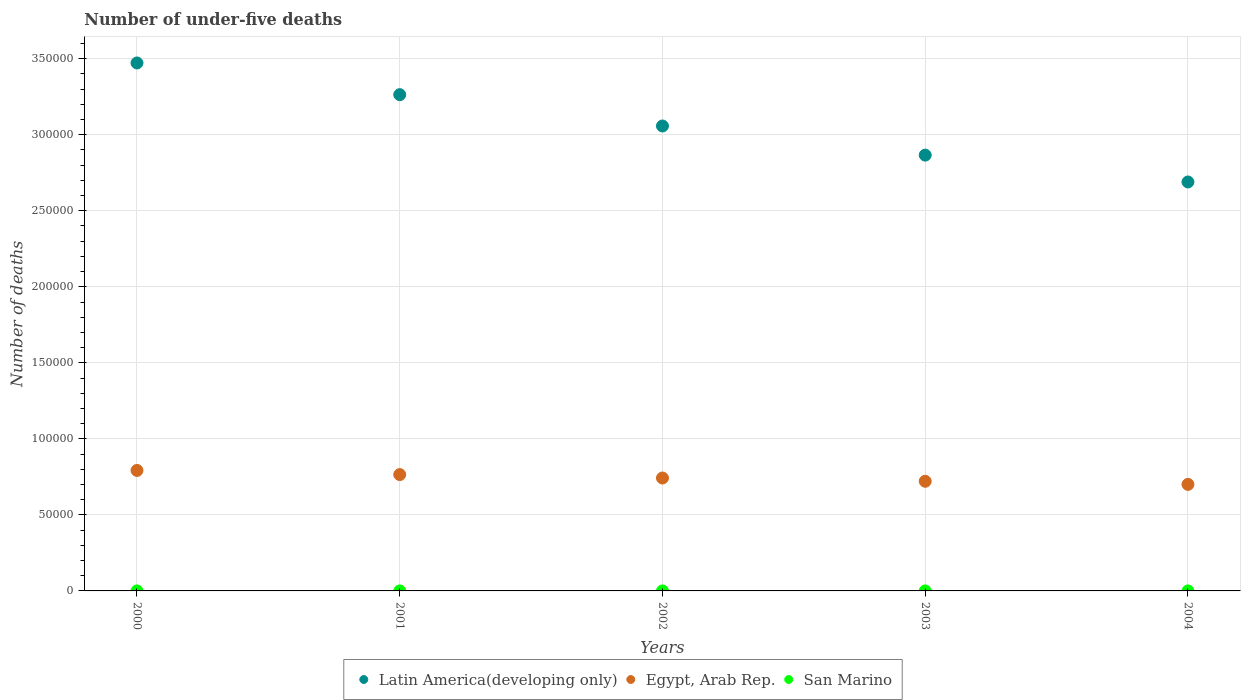What is the number of under-five deaths in Egypt, Arab Rep. in 2002?
Keep it short and to the point. 7.43e+04. Across all years, what is the maximum number of under-five deaths in Latin America(developing only)?
Provide a succinct answer. 3.47e+05. Across all years, what is the minimum number of under-five deaths in Latin America(developing only)?
Your answer should be very brief. 2.69e+05. What is the total number of under-five deaths in San Marino in the graph?
Keep it short and to the point. 5. What is the difference between the number of under-five deaths in Egypt, Arab Rep. in 2000 and that in 2004?
Offer a terse response. 9179. What is the difference between the number of under-five deaths in Latin America(developing only) in 2003 and the number of under-five deaths in San Marino in 2001?
Offer a terse response. 2.87e+05. What is the average number of under-five deaths in Egypt, Arab Rep. per year?
Your response must be concise. 7.44e+04. In the year 2003, what is the difference between the number of under-five deaths in San Marino and number of under-five deaths in Latin America(developing only)?
Make the answer very short. -2.87e+05. In how many years, is the number of under-five deaths in Egypt, Arab Rep. greater than 100000?
Your answer should be compact. 0. What is the ratio of the number of under-five deaths in Egypt, Arab Rep. in 2001 to that in 2002?
Your response must be concise. 1.03. Is the number of under-five deaths in Egypt, Arab Rep. in 2000 less than that in 2004?
Offer a terse response. No. Is the difference between the number of under-five deaths in San Marino in 2001 and 2004 greater than the difference between the number of under-five deaths in Latin America(developing only) in 2001 and 2004?
Your response must be concise. No. What is the difference between the highest and the second highest number of under-five deaths in Latin America(developing only)?
Provide a succinct answer. 2.08e+04. What is the difference between the highest and the lowest number of under-five deaths in Egypt, Arab Rep.?
Give a very brief answer. 9179. Is the sum of the number of under-five deaths in Egypt, Arab Rep. in 2000 and 2001 greater than the maximum number of under-five deaths in Latin America(developing only) across all years?
Give a very brief answer. No. Is it the case that in every year, the sum of the number of under-five deaths in Latin America(developing only) and number of under-five deaths in Egypt, Arab Rep.  is greater than the number of under-five deaths in San Marino?
Keep it short and to the point. Yes. How many dotlines are there?
Make the answer very short. 3. Are the values on the major ticks of Y-axis written in scientific E-notation?
Your response must be concise. No. Does the graph contain grids?
Provide a succinct answer. Yes. What is the title of the graph?
Your response must be concise. Number of under-five deaths. What is the label or title of the Y-axis?
Offer a very short reply. Number of deaths. What is the Number of deaths in Latin America(developing only) in 2000?
Offer a terse response. 3.47e+05. What is the Number of deaths in Egypt, Arab Rep. in 2000?
Your answer should be compact. 7.92e+04. What is the Number of deaths of San Marino in 2000?
Make the answer very short. 1. What is the Number of deaths in Latin America(developing only) in 2001?
Your answer should be very brief. 3.26e+05. What is the Number of deaths in Egypt, Arab Rep. in 2001?
Provide a succinct answer. 7.65e+04. What is the Number of deaths in Latin America(developing only) in 2002?
Keep it short and to the point. 3.06e+05. What is the Number of deaths of Egypt, Arab Rep. in 2002?
Provide a succinct answer. 7.43e+04. What is the Number of deaths in San Marino in 2002?
Ensure brevity in your answer.  1. What is the Number of deaths in Latin America(developing only) in 2003?
Offer a terse response. 2.87e+05. What is the Number of deaths in Egypt, Arab Rep. in 2003?
Provide a succinct answer. 7.21e+04. What is the Number of deaths in Latin America(developing only) in 2004?
Give a very brief answer. 2.69e+05. What is the Number of deaths in Egypt, Arab Rep. in 2004?
Make the answer very short. 7.01e+04. What is the Number of deaths of San Marino in 2004?
Provide a succinct answer. 1. Across all years, what is the maximum Number of deaths of Latin America(developing only)?
Offer a terse response. 3.47e+05. Across all years, what is the maximum Number of deaths in Egypt, Arab Rep.?
Provide a short and direct response. 7.92e+04. Across all years, what is the maximum Number of deaths of San Marino?
Ensure brevity in your answer.  1. Across all years, what is the minimum Number of deaths of Latin America(developing only)?
Provide a succinct answer. 2.69e+05. Across all years, what is the minimum Number of deaths of Egypt, Arab Rep.?
Offer a terse response. 7.01e+04. What is the total Number of deaths in Latin America(developing only) in the graph?
Your answer should be compact. 1.53e+06. What is the total Number of deaths of Egypt, Arab Rep. in the graph?
Your answer should be very brief. 3.72e+05. What is the total Number of deaths of San Marino in the graph?
Your answer should be very brief. 5. What is the difference between the Number of deaths in Latin America(developing only) in 2000 and that in 2001?
Make the answer very short. 2.08e+04. What is the difference between the Number of deaths of Egypt, Arab Rep. in 2000 and that in 2001?
Make the answer very short. 2722. What is the difference between the Number of deaths of San Marino in 2000 and that in 2001?
Make the answer very short. 0. What is the difference between the Number of deaths in Latin America(developing only) in 2000 and that in 2002?
Your answer should be compact. 4.14e+04. What is the difference between the Number of deaths in Egypt, Arab Rep. in 2000 and that in 2002?
Your answer should be compact. 4978. What is the difference between the Number of deaths in Latin America(developing only) in 2000 and that in 2003?
Give a very brief answer. 6.06e+04. What is the difference between the Number of deaths in Egypt, Arab Rep. in 2000 and that in 2003?
Provide a succinct answer. 7122. What is the difference between the Number of deaths of San Marino in 2000 and that in 2003?
Provide a succinct answer. 0. What is the difference between the Number of deaths in Latin America(developing only) in 2000 and that in 2004?
Your answer should be very brief. 7.83e+04. What is the difference between the Number of deaths of Egypt, Arab Rep. in 2000 and that in 2004?
Your answer should be compact. 9179. What is the difference between the Number of deaths in San Marino in 2000 and that in 2004?
Your answer should be very brief. 0. What is the difference between the Number of deaths in Latin America(developing only) in 2001 and that in 2002?
Give a very brief answer. 2.06e+04. What is the difference between the Number of deaths of Egypt, Arab Rep. in 2001 and that in 2002?
Your response must be concise. 2256. What is the difference between the Number of deaths in San Marino in 2001 and that in 2002?
Offer a terse response. 0. What is the difference between the Number of deaths in Latin America(developing only) in 2001 and that in 2003?
Your answer should be compact. 3.98e+04. What is the difference between the Number of deaths in Egypt, Arab Rep. in 2001 and that in 2003?
Your answer should be compact. 4400. What is the difference between the Number of deaths in Latin America(developing only) in 2001 and that in 2004?
Ensure brevity in your answer.  5.74e+04. What is the difference between the Number of deaths in Egypt, Arab Rep. in 2001 and that in 2004?
Your answer should be compact. 6457. What is the difference between the Number of deaths in Latin America(developing only) in 2002 and that in 2003?
Provide a short and direct response. 1.92e+04. What is the difference between the Number of deaths in Egypt, Arab Rep. in 2002 and that in 2003?
Offer a very short reply. 2144. What is the difference between the Number of deaths in San Marino in 2002 and that in 2003?
Keep it short and to the point. 0. What is the difference between the Number of deaths of Latin America(developing only) in 2002 and that in 2004?
Provide a short and direct response. 3.68e+04. What is the difference between the Number of deaths of Egypt, Arab Rep. in 2002 and that in 2004?
Keep it short and to the point. 4201. What is the difference between the Number of deaths in San Marino in 2002 and that in 2004?
Your answer should be very brief. 0. What is the difference between the Number of deaths of Latin America(developing only) in 2003 and that in 2004?
Provide a succinct answer. 1.77e+04. What is the difference between the Number of deaths of Egypt, Arab Rep. in 2003 and that in 2004?
Keep it short and to the point. 2057. What is the difference between the Number of deaths in San Marino in 2003 and that in 2004?
Keep it short and to the point. 0. What is the difference between the Number of deaths of Latin America(developing only) in 2000 and the Number of deaths of Egypt, Arab Rep. in 2001?
Provide a short and direct response. 2.71e+05. What is the difference between the Number of deaths in Latin America(developing only) in 2000 and the Number of deaths in San Marino in 2001?
Ensure brevity in your answer.  3.47e+05. What is the difference between the Number of deaths in Egypt, Arab Rep. in 2000 and the Number of deaths in San Marino in 2001?
Offer a terse response. 7.92e+04. What is the difference between the Number of deaths in Latin America(developing only) in 2000 and the Number of deaths in Egypt, Arab Rep. in 2002?
Ensure brevity in your answer.  2.73e+05. What is the difference between the Number of deaths of Latin America(developing only) in 2000 and the Number of deaths of San Marino in 2002?
Give a very brief answer. 3.47e+05. What is the difference between the Number of deaths in Egypt, Arab Rep. in 2000 and the Number of deaths in San Marino in 2002?
Offer a terse response. 7.92e+04. What is the difference between the Number of deaths in Latin America(developing only) in 2000 and the Number of deaths in Egypt, Arab Rep. in 2003?
Your response must be concise. 2.75e+05. What is the difference between the Number of deaths of Latin America(developing only) in 2000 and the Number of deaths of San Marino in 2003?
Make the answer very short. 3.47e+05. What is the difference between the Number of deaths of Egypt, Arab Rep. in 2000 and the Number of deaths of San Marino in 2003?
Keep it short and to the point. 7.92e+04. What is the difference between the Number of deaths of Latin America(developing only) in 2000 and the Number of deaths of Egypt, Arab Rep. in 2004?
Ensure brevity in your answer.  2.77e+05. What is the difference between the Number of deaths in Latin America(developing only) in 2000 and the Number of deaths in San Marino in 2004?
Your response must be concise. 3.47e+05. What is the difference between the Number of deaths in Egypt, Arab Rep. in 2000 and the Number of deaths in San Marino in 2004?
Keep it short and to the point. 7.92e+04. What is the difference between the Number of deaths in Latin America(developing only) in 2001 and the Number of deaths in Egypt, Arab Rep. in 2002?
Your response must be concise. 2.52e+05. What is the difference between the Number of deaths in Latin America(developing only) in 2001 and the Number of deaths in San Marino in 2002?
Give a very brief answer. 3.26e+05. What is the difference between the Number of deaths of Egypt, Arab Rep. in 2001 and the Number of deaths of San Marino in 2002?
Make the answer very short. 7.65e+04. What is the difference between the Number of deaths of Latin America(developing only) in 2001 and the Number of deaths of Egypt, Arab Rep. in 2003?
Your answer should be compact. 2.54e+05. What is the difference between the Number of deaths in Latin America(developing only) in 2001 and the Number of deaths in San Marino in 2003?
Your answer should be very brief. 3.26e+05. What is the difference between the Number of deaths of Egypt, Arab Rep. in 2001 and the Number of deaths of San Marino in 2003?
Your answer should be very brief. 7.65e+04. What is the difference between the Number of deaths in Latin America(developing only) in 2001 and the Number of deaths in Egypt, Arab Rep. in 2004?
Your answer should be very brief. 2.56e+05. What is the difference between the Number of deaths of Latin America(developing only) in 2001 and the Number of deaths of San Marino in 2004?
Make the answer very short. 3.26e+05. What is the difference between the Number of deaths in Egypt, Arab Rep. in 2001 and the Number of deaths in San Marino in 2004?
Keep it short and to the point. 7.65e+04. What is the difference between the Number of deaths of Latin America(developing only) in 2002 and the Number of deaths of Egypt, Arab Rep. in 2003?
Make the answer very short. 2.34e+05. What is the difference between the Number of deaths of Latin America(developing only) in 2002 and the Number of deaths of San Marino in 2003?
Your answer should be very brief. 3.06e+05. What is the difference between the Number of deaths of Egypt, Arab Rep. in 2002 and the Number of deaths of San Marino in 2003?
Keep it short and to the point. 7.43e+04. What is the difference between the Number of deaths in Latin America(developing only) in 2002 and the Number of deaths in Egypt, Arab Rep. in 2004?
Keep it short and to the point. 2.36e+05. What is the difference between the Number of deaths of Latin America(developing only) in 2002 and the Number of deaths of San Marino in 2004?
Ensure brevity in your answer.  3.06e+05. What is the difference between the Number of deaths of Egypt, Arab Rep. in 2002 and the Number of deaths of San Marino in 2004?
Provide a succinct answer. 7.43e+04. What is the difference between the Number of deaths in Latin America(developing only) in 2003 and the Number of deaths in Egypt, Arab Rep. in 2004?
Provide a succinct answer. 2.17e+05. What is the difference between the Number of deaths in Latin America(developing only) in 2003 and the Number of deaths in San Marino in 2004?
Offer a terse response. 2.87e+05. What is the difference between the Number of deaths of Egypt, Arab Rep. in 2003 and the Number of deaths of San Marino in 2004?
Ensure brevity in your answer.  7.21e+04. What is the average Number of deaths of Latin America(developing only) per year?
Your response must be concise. 3.07e+05. What is the average Number of deaths in Egypt, Arab Rep. per year?
Offer a very short reply. 7.44e+04. In the year 2000, what is the difference between the Number of deaths in Latin America(developing only) and Number of deaths in Egypt, Arab Rep.?
Offer a terse response. 2.68e+05. In the year 2000, what is the difference between the Number of deaths of Latin America(developing only) and Number of deaths of San Marino?
Provide a short and direct response. 3.47e+05. In the year 2000, what is the difference between the Number of deaths in Egypt, Arab Rep. and Number of deaths in San Marino?
Keep it short and to the point. 7.92e+04. In the year 2001, what is the difference between the Number of deaths of Latin America(developing only) and Number of deaths of Egypt, Arab Rep.?
Your answer should be very brief. 2.50e+05. In the year 2001, what is the difference between the Number of deaths in Latin America(developing only) and Number of deaths in San Marino?
Your response must be concise. 3.26e+05. In the year 2001, what is the difference between the Number of deaths in Egypt, Arab Rep. and Number of deaths in San Marino?
Your answer should be very brief. 7.65e+04. In the year 2002, what is the difference between the Number of deaths in Latin America(developing only) and Number of deaths in Egypt, Arab Rep.?
Make the answer very short. 2.31e+05. In the year 2002, what is the difference between the Number of deaths in Latin America(developing only) and Number of deaths in San Marino?
Your answer should be very brief. 3.06e+05. In the year 2002, what is the difference between the Number of deaths of Egypt, Arab Rep. and Number of deaths of San Marino?
Ensure brevity in your answer.  7.43e+04. In the year 2003, what is the difference between the Number of deaths of Latin America(developing only) and Number of deaths of Egypt, Arab Rep.?
Your answer should be compact. 2.14e+05. In the year 2003, what is the difference between the Number of deaths of Latin America(developing only) and Number of deaths of San Marino?
Provide a short and direct response. 2.87e+05. In the year 2003, what is the difference between the Number of deaths of Egypt, Arab Rep. and Number of deaths of San Marino?
Keep it short and to the point. 7.21e+04. In the year 2004, what is the difference between the Number of deaths in Latin America(developing only) and Number of deaths in Egypt, Arab Rep.?
Your answer should be very brief. 1.99e+05. In the year 2004, what is the difference between the Number of deaths in Latin America(developing only) and Number of deaths in San Marino?
Make the answer very short. 2.69e+05. In the year 2004, what is the difference between the Number of deaths of Egypt, Arab Rep. and Number of deaths of San Marino?
Your answer should be very brief. 7.01e+04. What is the ratio of the Number of deaths of Latin America(developing only) in 2000 to that in 2001?
Give a very brief answer. 1.06. What is the ratio of the Number of deaths in Egypt, Arab Rep. in 2000 to that in 2001?
Give a very brief answer. 1.04. What is the ratio of the Number of deaths in San Marino in 2000 to that in 2001?
Provide a short and direct response. 1. What is the ratio of the Number of deaths of Latin America(developing only) in 2000 to that in 2002?
Your response must be concise. 1.14. What is the ratio of the Number of deaths in Egypt, Arab Rep. in 2000 to that in 2002?
Make the answer very short. 1.07. What is the ratio of the Number of deaths in San Marino in 2000 to that in 2002?
Your response must be concise. 1. What is the ratio of the Number of deaths of Latin America(developing only) in 2000 to that in 2003?
Provide a short and direct response. 1.21. What is the ratio of the Number of deaths of Egypt, Arab Rep. in 2000 to that in 2003?
Your response must be concise. 1.1. What is the ratio of the Number of deaths in Latin America(developing only) in 2000 to that in 2004?
Offer a very short reply. 1.29. What is the ratio of the Number of deaths of Egypt, Arab Rep. in 2000 to that in 2004?
Your answer should be compact. 1.13. What is the ratio of the Number of deaths in San Marino in 2000 to that in 2004?
Your answer should be compact. 1. What is the ratio of the Number of deaths in Latin America(developing only) in 2001 to that in 2002?
Make the answer very short. 1.07. What is the ratio of the Number of deaths of Egypt, Arab Rep. in 2001 to that in 2002?
Keep it short and to the point. 1.03. What is the ratio of the Number of deaths in Latin America(developing only) in 2001 to that in 2003?
Keep it short and to the point. 1.14. What is the ratio of the Number of deaths in Egypt, Arab Rep. in 2001 to that in 2003?
Your response must be concise. 1.06. What is the ratio of the Number of deaths in San Marino in 2001 to that in 2003?
Ensure brevity in your answer.  1. What is the ratio of the Number of deaths of Latin America(developing only) in 2001 to that in 2004?
Make the answer very short. 1.21. What is the ratio of the Number of deaths in Egypt, Arab Rep. in 2001 to that in 2004?
Offer a very short reply. 1.09. What is the ratio of the Number of deaths in Latin America(developing only) in 2002 to that in 2003?
Your answer should be compact. 1.07. What is the ratio of the Number of deaths in Egypt, Arab Rep. in 2002 to that in 2003?
Offer a very short reply. 1.03. What is the ratio of the Number of deaths in Latin America(developing only) in 2002 to that in 2004?
Offer a very short reply. 1.14. What is the ratio of the Number of deaths of Egypt, Arab Rep. in 2002 to that in 2004?
Provide a succinct answer. 1.06. What is the ratio of the Number of deaths of San Marino in 2002 to that in 2004?
Give a very brief answer. 1. What is the ratio of the Number of deaths of Latin America(developing only) in 2003 to that in 2004?
Your answer should be very brief. 1.07. What is the ratio of the Number of deaths in Egypt, Arab Rep. in 2003 to that in 2004?
Make the answer very short. 1.03. What is the ratio of the Number of deaths in San Marino in 2003 to that in 2004?
Offer a terse response. 1. What is the difference between the highest and the second highest Number of deaths in Latin America(developing only)?
Your answer should be very brief. 2.08e+04. What is the difference between the highest and the second highest Number of deaths in Egypt, Arab Rep.?
Your answer should be very brief. 2722. What is the difference between the highest and the second highest Number of deaths of San Marino?
Offer a terse response. 0. What is the difference between the highest and the lowest Number of deaths of Latin America(developing only)?
Give a very brief answer. 7.83e+04. What is the difference between the highest and the lowest Number of deaths of Egypt, Arab Rep.?
Offer a very short reply. 9179. 